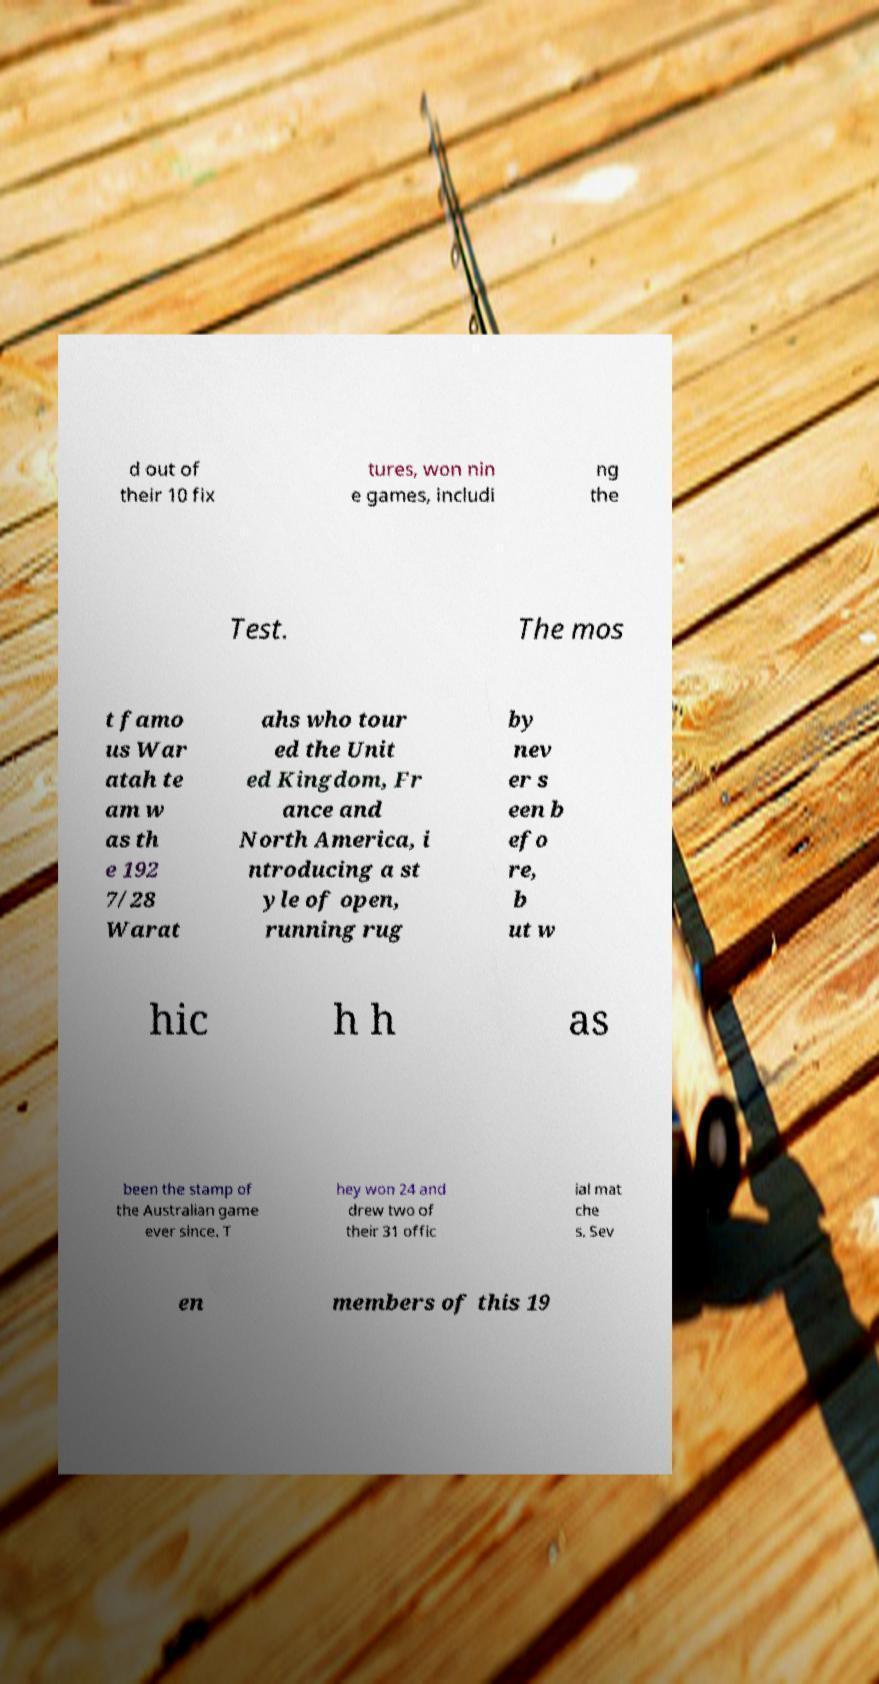I need the written content from this picture converted into text. Can you do that? d out of their 10 fix tures, won nin e games, includi ng the Test. The mos t famo us War atah te am w as th e 192 7/28 Warat ahs who tour ed the Unit ed Kingdom, Fr ance and North America, i ntroducing a st yle of open, running rug by nev er s een b efo re, b ut w hic h h as been the stamp of the Australian game ever since. T hey won 24 and drew two of their 31 offic ial mat che s. Sev en members of this 19 